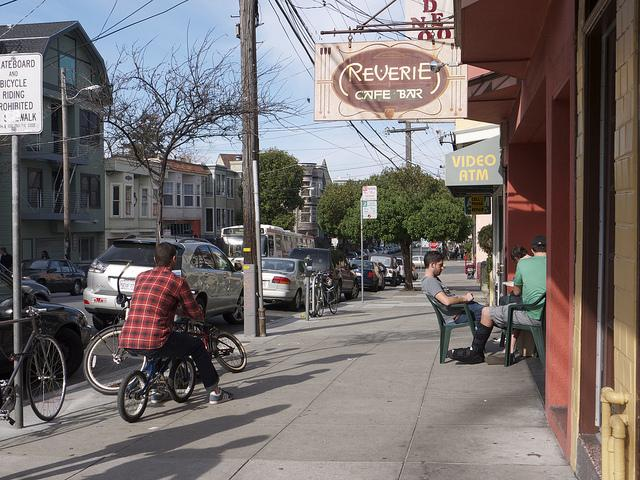What can the men do here? ride bikes 